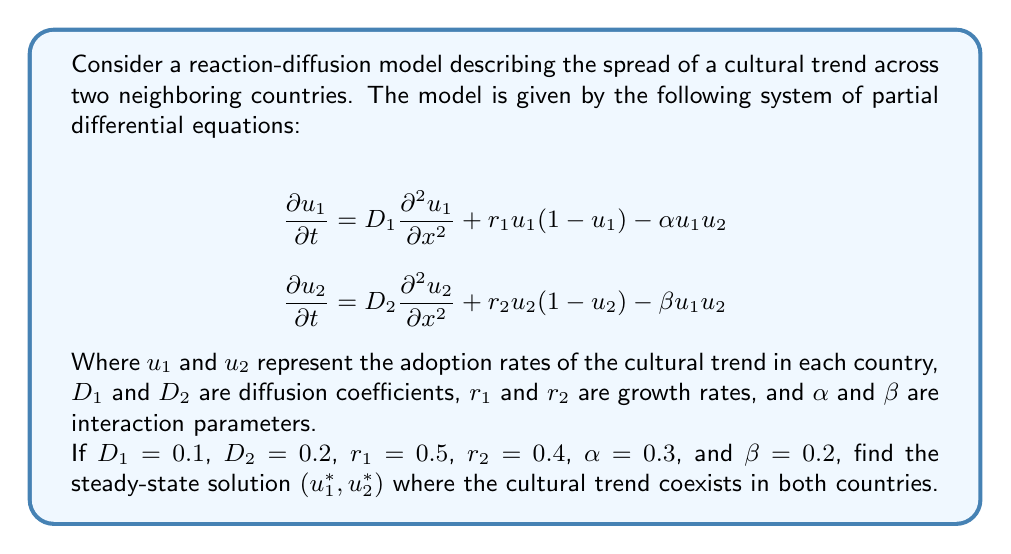Give your solution to this math problem. To find the steady-state solution, we need to set the time derivatives to zero:

$$\begin{align}
0 &= D_1 \frac{\partial^2 u_1}{\partial x^2} + r_1 u_1 (1 - u_1) - \alpha u_1 u_2 \\
0 &= D_2 \frac{\partial^2 u_2}{\partial x^2} + r_2 u_2 (1 - u_2) - \beta u_1 u_2
\end{align}$$

For a homogeneous steady state, spatial derivatives are zero:

$$\begin{align}
0 &= r_1 u_1 (1 - u_1) - \alpha u_1 u_2 \\
0 &= r_2 u_2 (1 - u_2) - \beta u_1 u_2
\end{align}$$

Substituting the given values:

$$\begin{align}
0 &= 0.5 u_1 (1 - u_1) - 0.3 u_1 u_2 \\
0 &= 0.4 u_2 (1 - u_2) - 0.2 u_1 u_2
\end{align}$$

Rearranging:

$$\begin{align}
0.5 - 0.5 u_1 - 0.3 u_2 &= 0 \\
0.4 - 0.4 u_2 - 0.2 u_1 &= 0
\end{align}$$

Solving this system of linear equations:

$$\begin{align}
u_1 &= 1 - 0.6 u_2 \\
u_2 &= 1 - 0.5 u_1
\end{align}$$

Substituting the first equation into the second:

$$\begin{align}
u_2 &= 1 - 0.5(1 - 0.6 u_2) \\
u_2 &= 1 - 0.5 + 0.3 u_2 \\
0.7 u_2 &= 0.5 \\
u_2 &= \frac{5}{7}
\end{align}$$

Substituting back to find $u_1$:

$$\begin{align}
u_1 &= 1 - 0.6 \cdot \frac{5}{7} \\
u_1 &= 1 - \frac{3}{7} = \frac{4}{7}
\end{align}$$

Therefore, the steady-state solution is $(u_1^*, u_2^*) = (\frac{4}{7}, \frac{5}{7})$.
Answer: $(\frac{4}{7}, \frac{5}{7})$ 